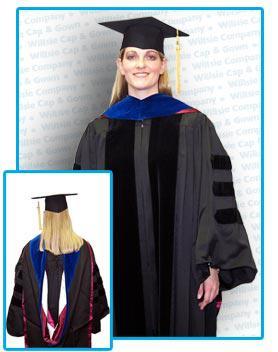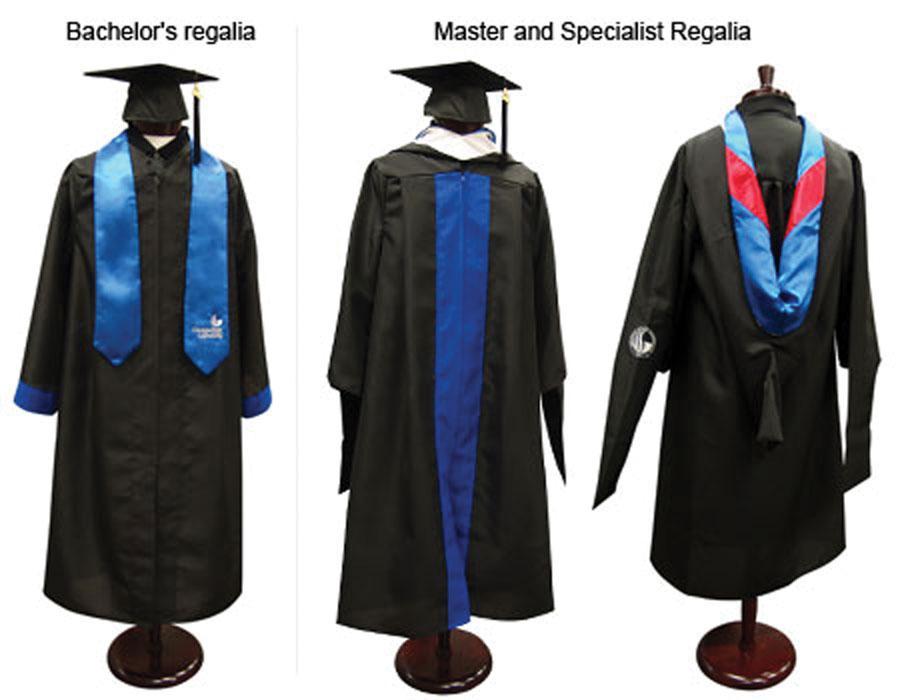The first image is the image on the left, the second image is the image on the right. For the images displayed, is the sentence "There are three people in one of the images." factually correct? Answer yes or no. No. 